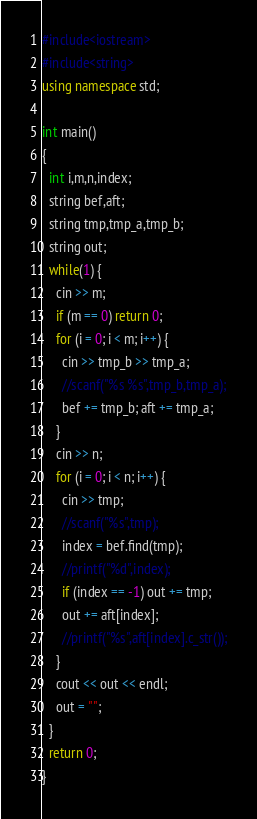<code> <loc_0><loc_0><loc_500><loc_500><_C++_>#include<iostream>
#include<string>
using namespace std;

int main()
{
  int i,m,n,index;
  string bef,aft;
  string tmp,tmp_a,tmp_b;
  string out;
  while(1) {
    cin >> m;
    if (m == 0) return 0;
    for (i = 0; i < m; i++) {
      cin >> tmp_b >> tmp_a;
      //scanf("%s %s",tmp_b,tmp_a);
      bef += tmp_b; aft += tmp_a;
    }
    cin >> n;
    for (i = 0; i < n; i++) {
      cin >> tmp;
      //scanf("%s",tmp);
      index = bef.find(tmp);
      //printf("%d",index);
      if (index == -1) out += tmp;
      out += aft[index];
      //printf("%s",aft[index].c_str());
    }
    cout << out << endl;
    out = "";
  }
  return 0;
}</code> 